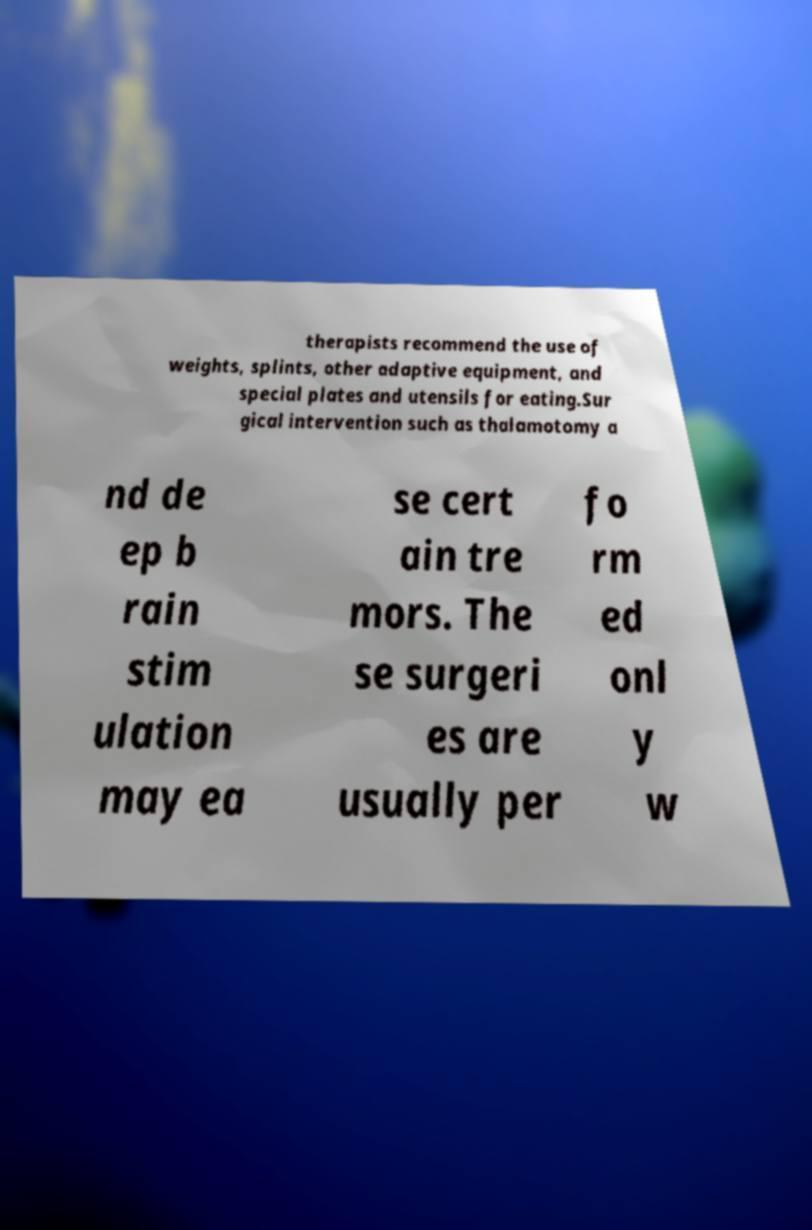Please read and relay the text visible in this image. What does it say? therapists recommend the use of weights, splints, other adaptive equipment, and special plates and utensils for eating.Sur gical intervention such as thalamotomy a nd de ep b rain stim ulation may ea se cert ain tre mors. The se surgeri es are usually per fo rm ed onl y w 